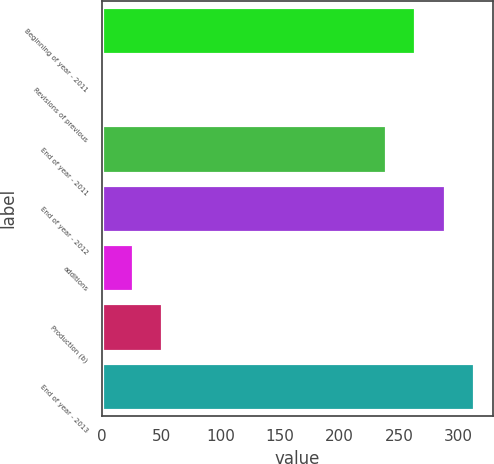Convert chart. <chart><loc_0><loc_0><loc_500><loc_500><bar_chart><fcel>Beginning of year - 2011<fcel>Revisions of previous<fcel>End of year - 2011<fcel>End of year - 2012<fcel>additions<fcel>Production (b)<fcel>End of year - 2013<nl><fcel>263.8<fcel>1<fcel>239<fcel>288.6<fcel>25.8<fcel>50.6<fcel>313.4<nl></chart> 